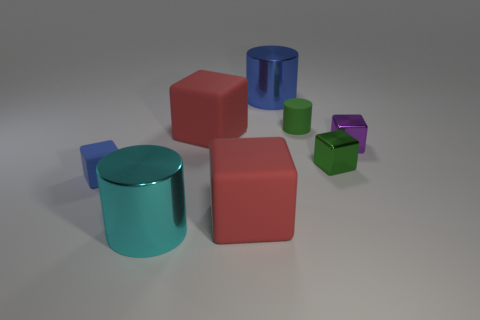Subtract all green matte cylinders. How many cylinders are left? 2 Add 1 small blue matte things. How many objects exist? 9 Subtract all brown cylinders. How many red cubes are left? 2 Subtract all blue cylinders. How many cylinders are left? 2 Subtract all cubes. How many objects are left? 3 Subtract 4 blocks. How many blocks are left? 1 Add 3 matte cubes. How many matte cubes are left? 6 Add 5 big yellow metal cubes. How many big yellow metal cubes exist? 5 Subtract 0 red cylinders. How many objects are left? 8 Subtract all cyan cubes. Subtract all yellow spheres. How many cubes are left? 5 